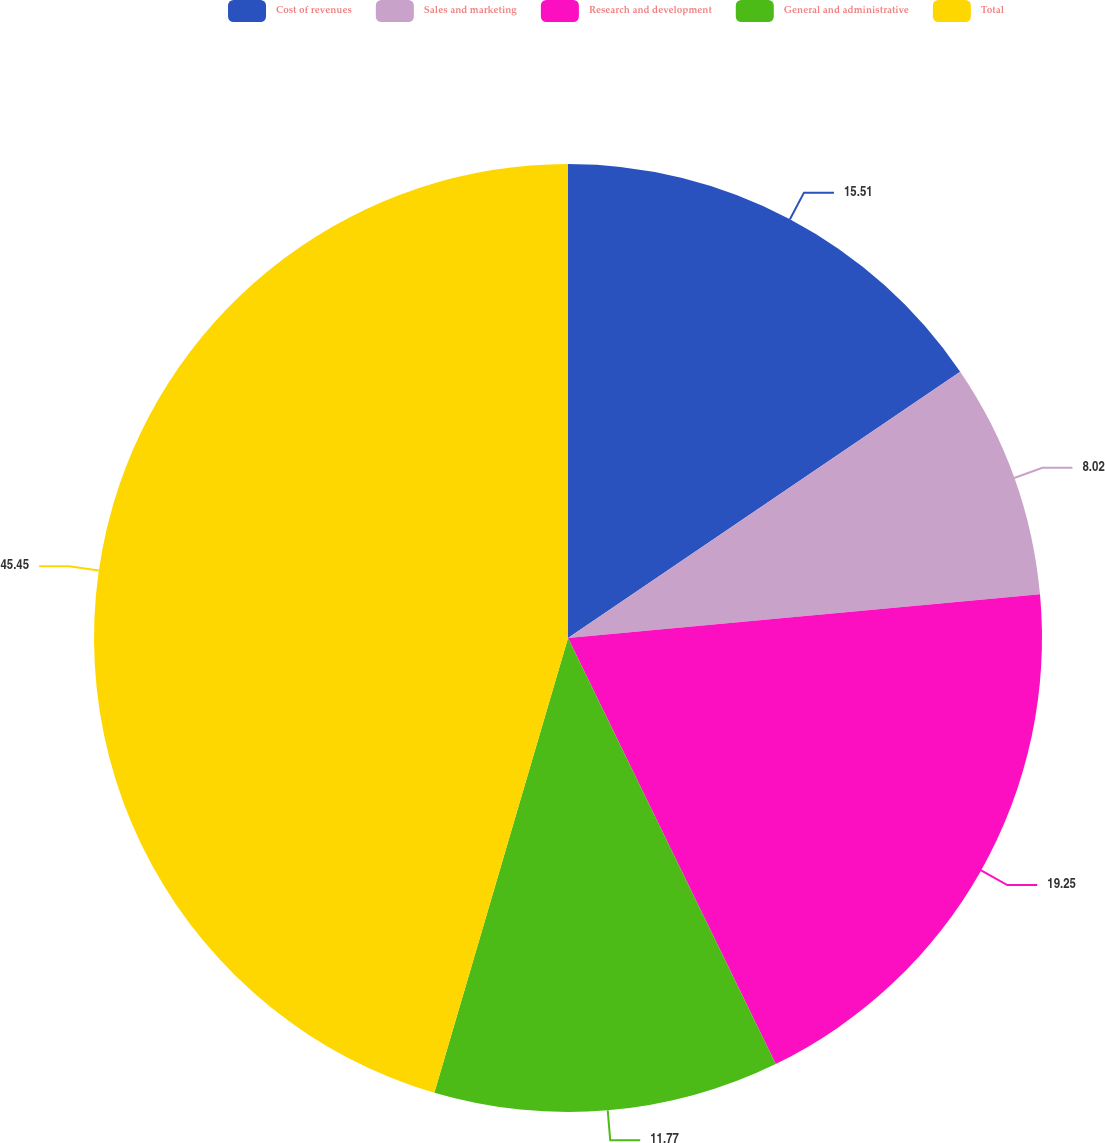Convert chart. <chart><loc_0><loc_0><loc_500><loc_500><pie_chart><fcel>Cost of revenues<fcel>Sales and marketing<fcel>Research and development<fcel>General and administrative<fcel>Total<nl><fcel>15.51%<fcel>8.02%<fcel>19.25%<fcel>11.77%<fcel>45.45%<nl></chart> 